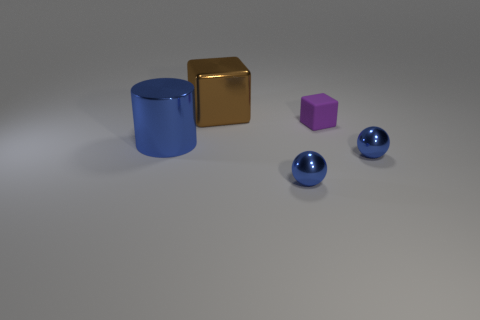Add 1 small blue rubber cylinders. How many objects exist? 6 Subtract all cylinders. How many objects are left? 4 Subtract 1 blue spheres. How many objects are left? 4 Subtract all big matte objects. Subtract all metal cubes. How many objects are left? 4 Add 4 tiny purple rubber things. How many tiny purple rubber things are left? 5 Add 5 purple things. How many purple things exist? 6 